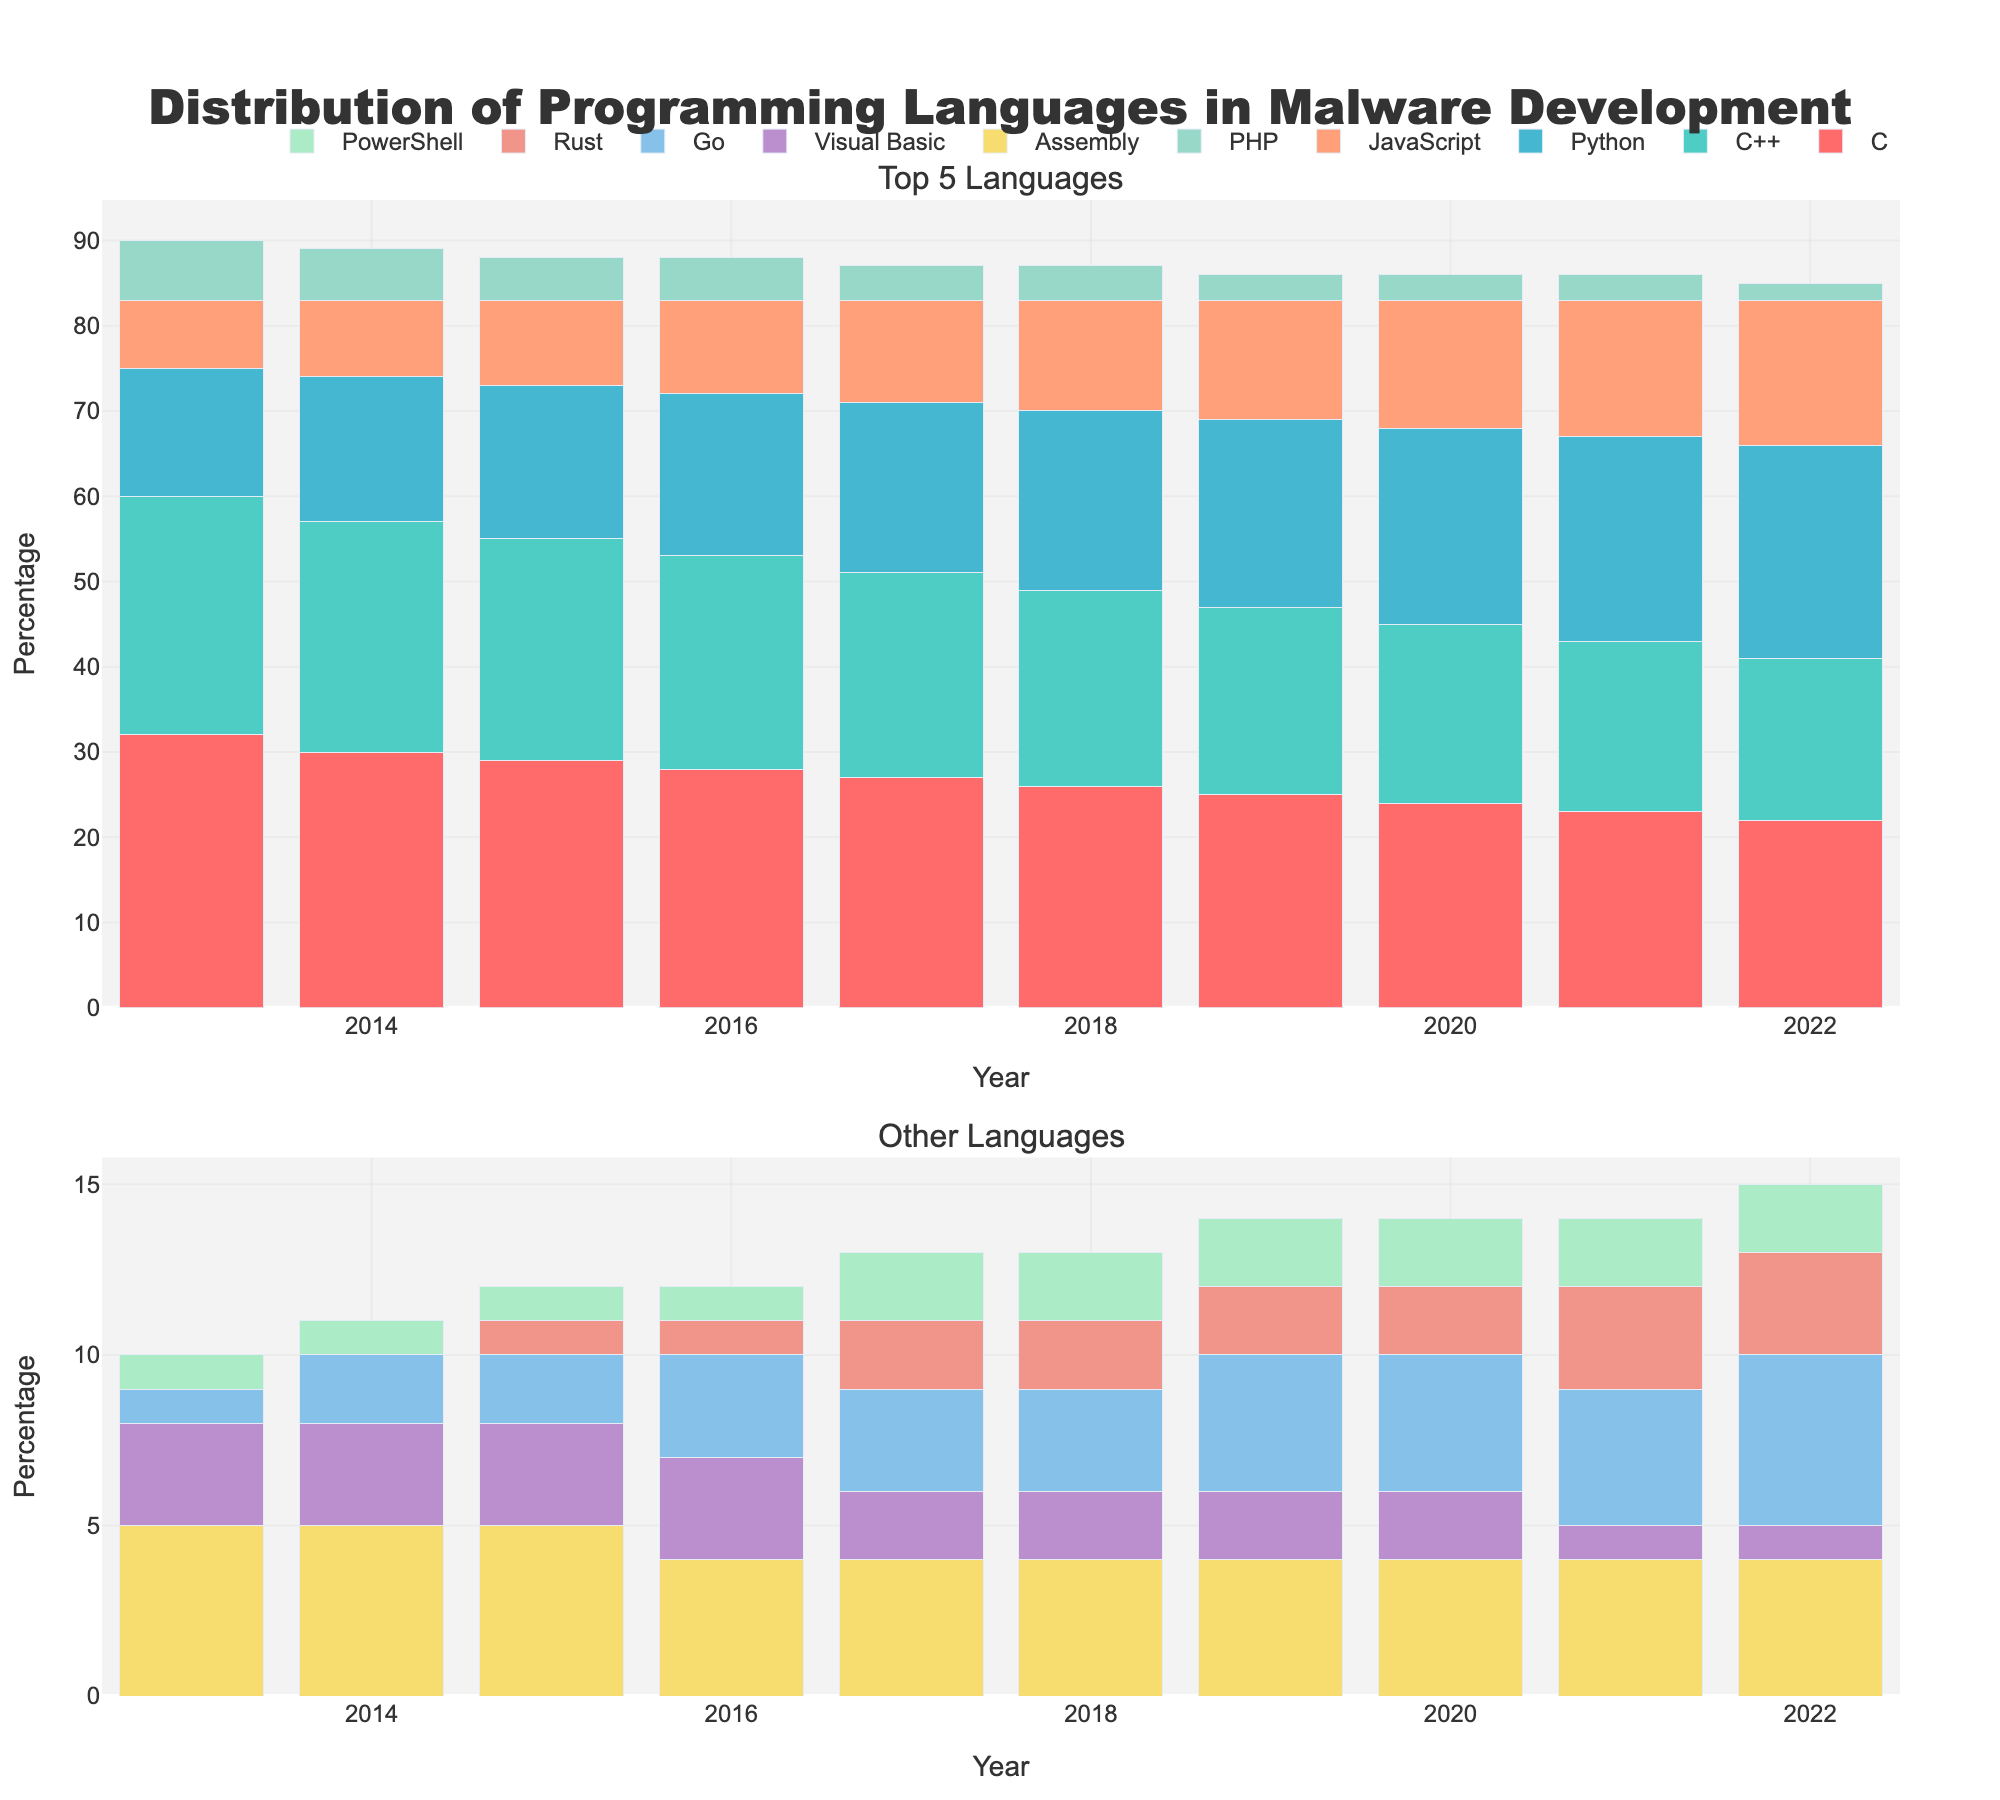In which year did Python first surpass C++ in usage? By observing the heights of the bars for Python and C++ over the years, we can see that Python first surpasses C++ in 2020.
Answer: 2020 Between 2014 and 2016, which language experienced a decrease in usage? From 2014 to 2016, C, C++, JavaScript, and PHP show a decrease in terms of bar height. Observing the colors and heights of the bars confirms this.
Answer: C, C++, JavaScript, PHP Comparing 2019 and 2022, by how much did the combined percentage of C and C++ decline? To find the combined decline, calculate the sum of C and C++ for both years (2019: 25 + 22 = 47, 2022: 22 + 19 = 41) and then find the difference (47 - 41 = 6).
Answer: 6 Which programming language had the most significant increase in usage from 2013 to 2022? By observing the stacked bars, Python shows the tallest growth over the years, increasing consistently from 15 to 25.
Answer: Python What is the average usage percentage of Assembly language between 2013 and 2022? To find the average, sum Assembly's values over the years (5 + 5 + 5 + 4 + 4 + 4 + 4 + 4 + 4 + 4 = 43) and divide by the number of years (43 / 10 = 4.3).
Answer: 4.3 Which languages consistently had less than 5% usage throughout the decade? Observing all bar heights in both subplots, Visual Basic and PowerShell consistently remain below the 5% mark.
Answer: Visual Basic, PowerShell In what year did Go usage reach 3% for the first time? Observing the Go bar heights, 2017 is the first year it reaches and stays at 3%.
Answer: 2017 By how much did JavaScript's usage increase from 2013 to 2022? Calculating the difference in heights, JavaScript started at 8% in 2013 and reached 17% in 2022 (17 - 8 = 9).
Answer: 9 Which year showed equal usage of Visual Basic and PowerShell? Observing the heights of the bars, both Visual Basic and PowerShell share the same height in 2019 and 2020.
Answer: 2019, 2020 